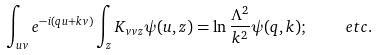Convert formula to latex. <formula><loc_0><loc_0><loc_500><loc_500>\int _ { u v } e ^ { - i ( q u + k v ) } \int _ { z } K _ { v v z } \psi ( u , z ) = \ln \frac { \Lambda ^ { 2 } } { k ^ { 2 } } \psi ( q , k ) ; \quad \ e t c .</formula> 